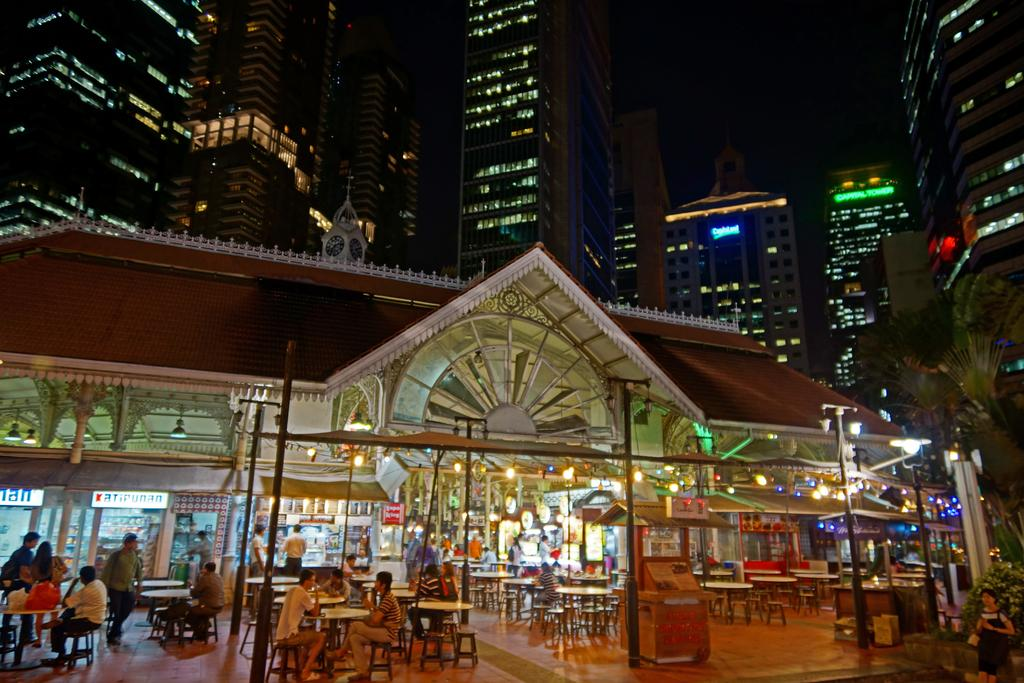What type of structures can be seen in the image? There are buildings with windows in the image. What is present in front of the store? There are lights, a table, boards, and light poles in front of the store. What else can be seen in front of the store? There are people in front of the store. What natural element is visible in the image? There is a tree in the image. What type of cord is being used to hold the page in the image? There is no cord or page present in the image. What kind of pie is being served on the table in the image? There is no pie present in the image; only a table is visible. 